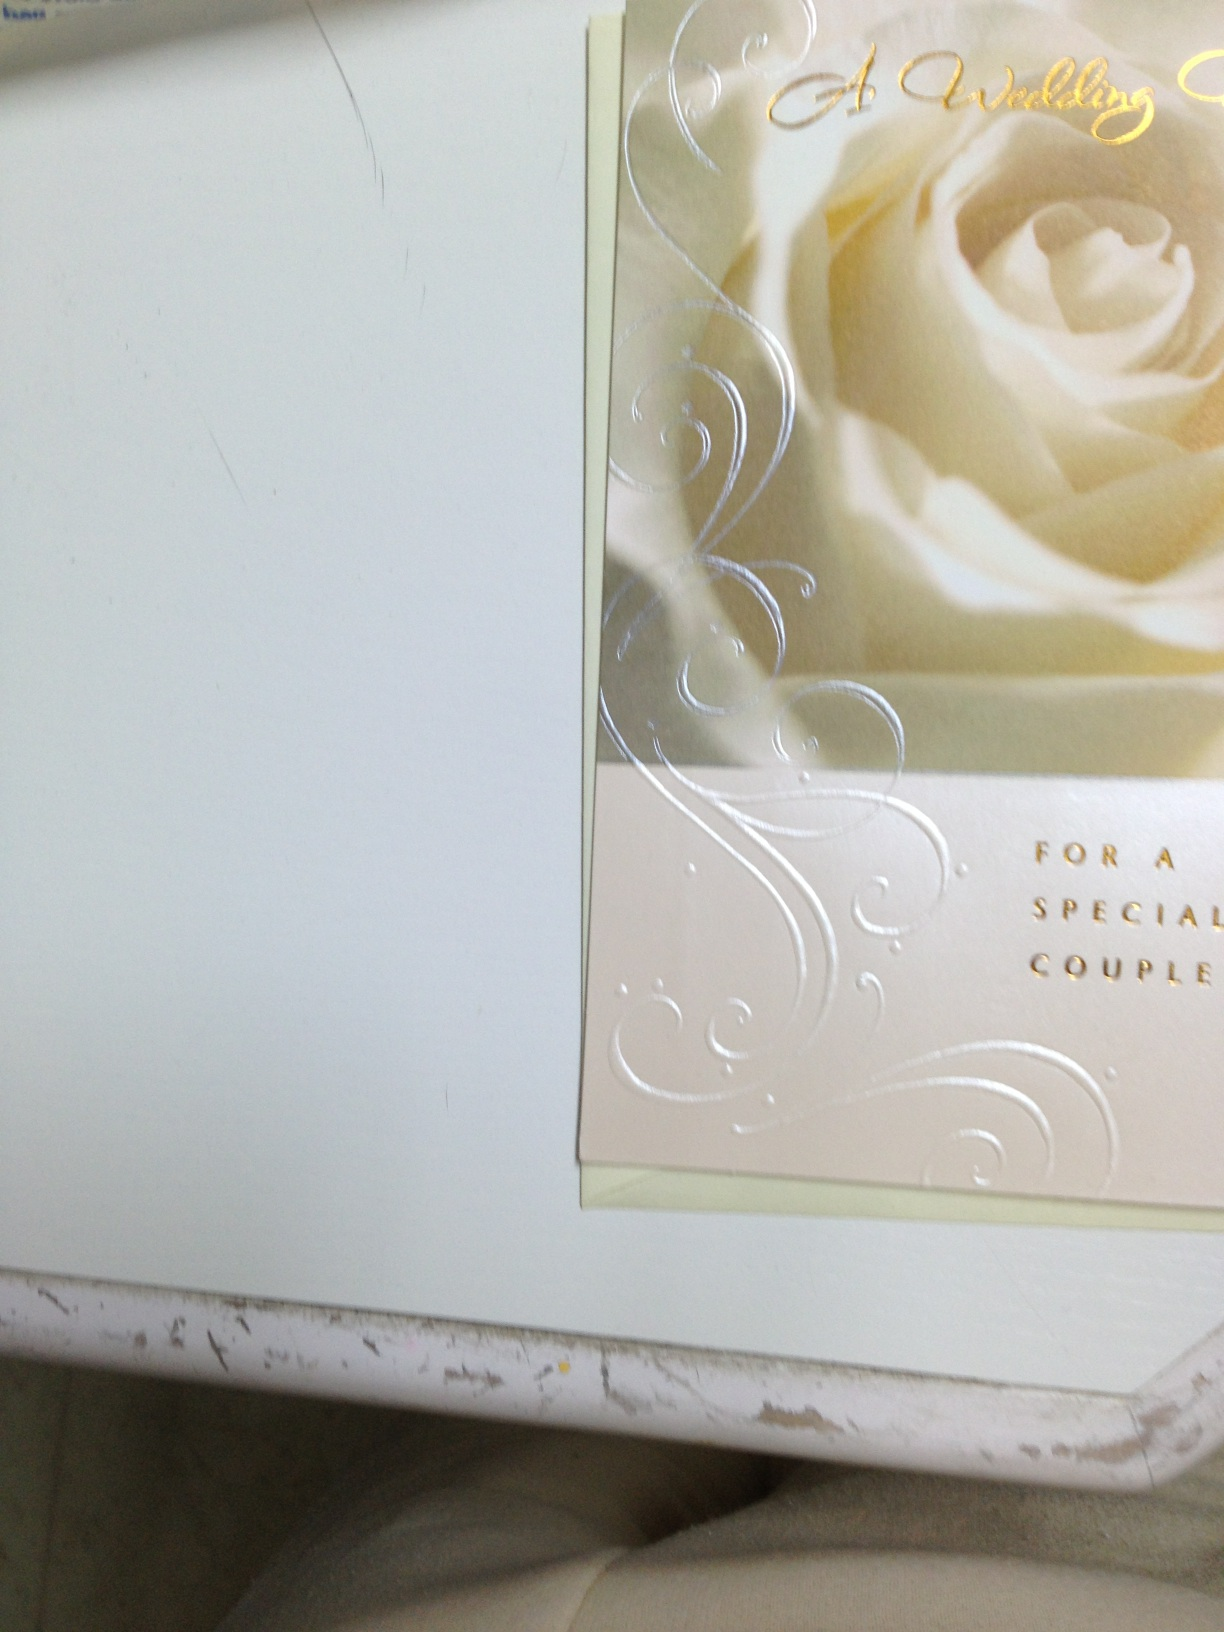Can you tell me more about the design elements used in this wedding card? Certainly! The wedding card includes a photograph of a pale, soft-focus rose, which symbolizes love and purity. The card also features swirling white patterns that add a touch of elegance and sophistication. Gold script text further enhances the luxe feel of the card, suitable for celebrating a special union. What does the gold script on the card say? The gold script on the card reads 'A Wedding Gift for a Special Couple,' emphasizing the card's purpose to celebrate a loving partnership and marking a significant life event in a couple's journey together. 